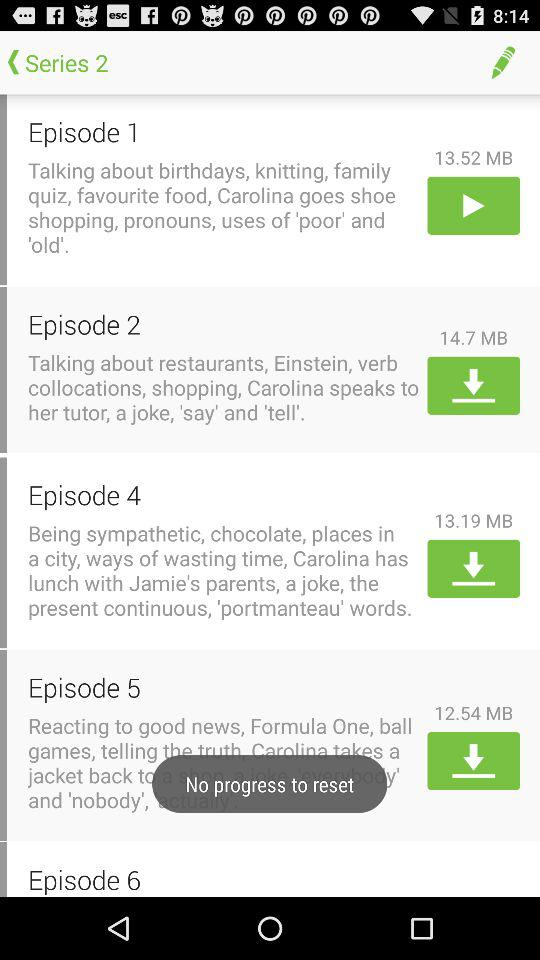Which series episodes are shown? The episodes are from Series 2. 